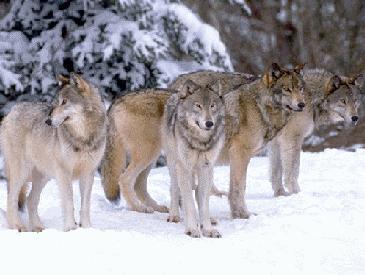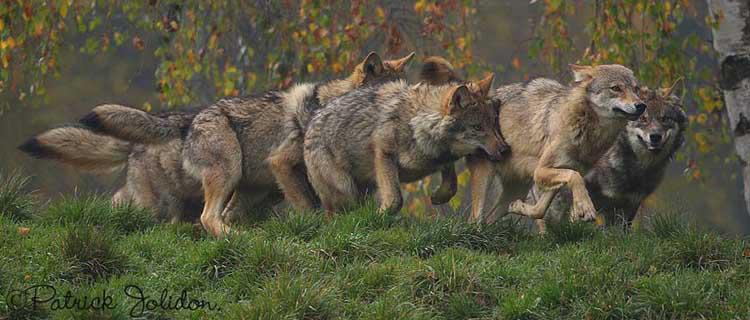The first image is the image on the left, the second image is the image on the right. Assess this claim about the two images: "There are five wolves in total.". Correct or not? Answer yes or no. No. 